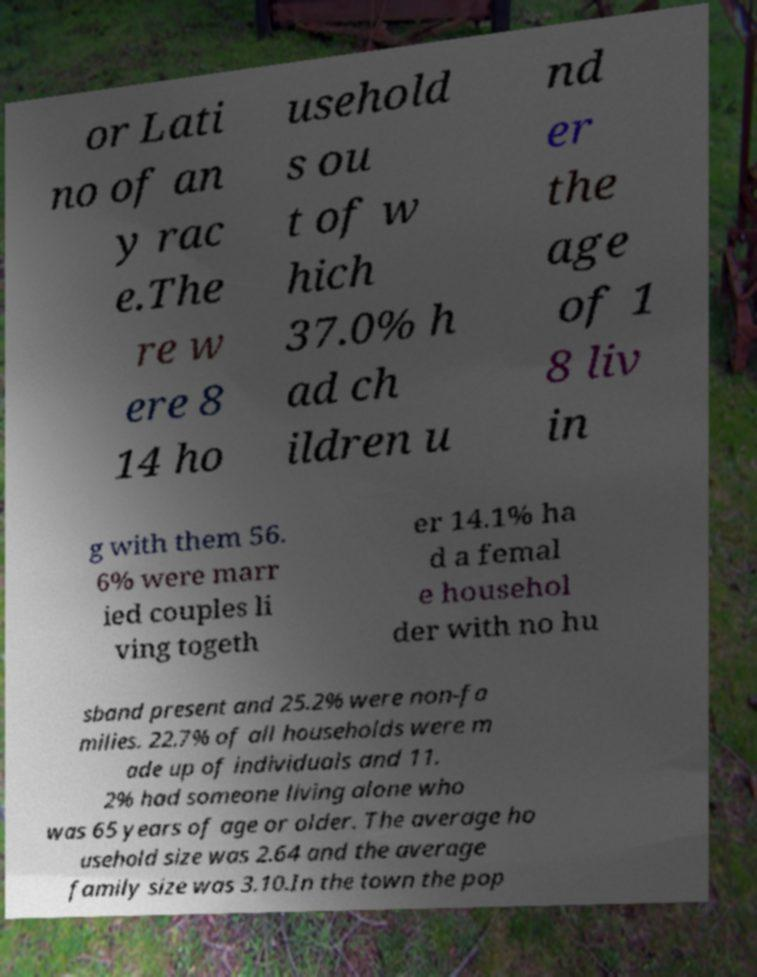Could you extract and type out the text from this image? or Lati no of an y rac e.The re w ere 8 14 ho usehold s ou t of w hich 37.0% h ad ch ildren u nd er the age of 1 8 liv in g with them 56. 6% were marr ied couples li ving togeth er 14.1% ha d a femal e househol der with no hu sband present and 25.2% were non-fa milies. 22.7% of all households were m ade up of individuals and 11. 2% had someone living alone who was 65 years of age or older. The average ho usehold size was 2.64 and the average family size was 3.10.In the town the pop 